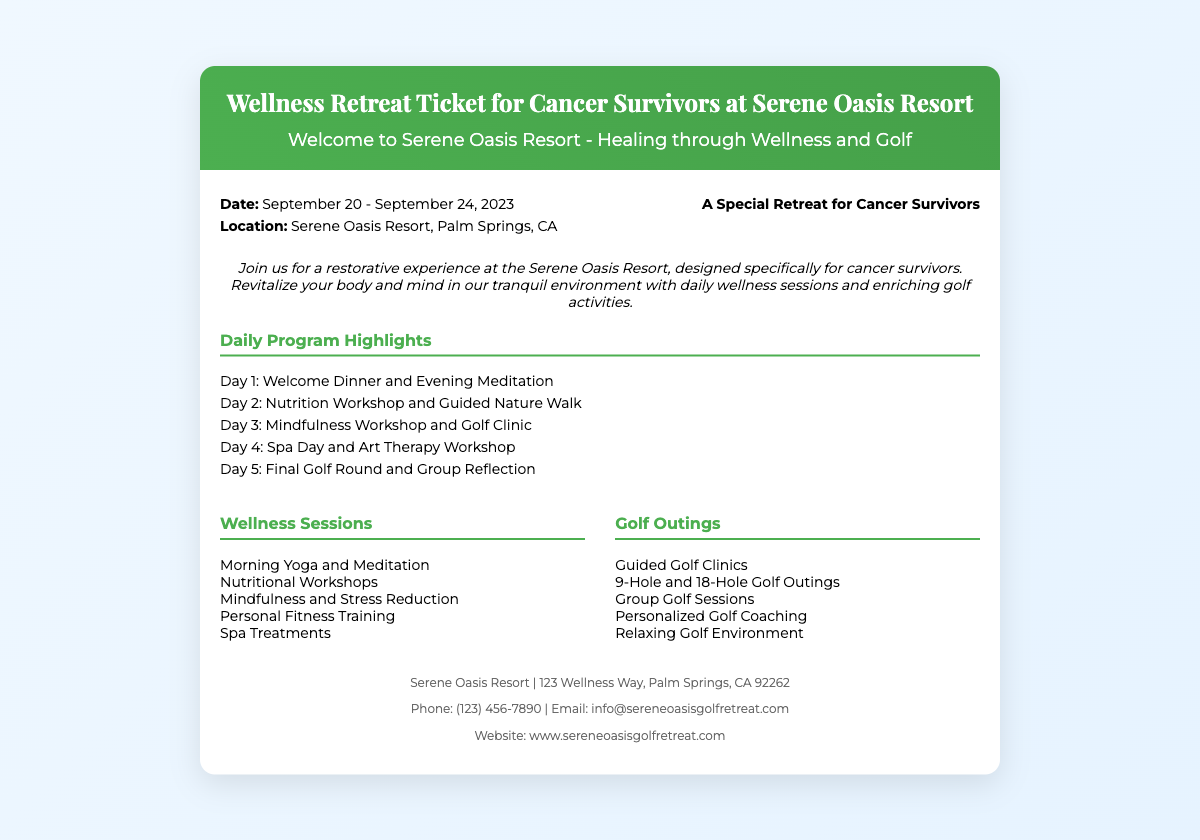what are the dates of the retreat? The document states the retreat starts on September 20 and ends on September 24, 2023.
Answer: September 20 - September 24, 2023 what is the location of the retreat? The ticket provides information about the retreat location being Serene Oasis Resort, Palm Springs, CA.
Answer: Serene Oasis Resort, Palm Springs, CA what is included in the welcome program? The introduction mentions a welcome dinner and evening meditation on the first day as part of the daily program highlights.
Answer: Welcome Dinner and Evening Meditation how many days does the retreat last? The duration of the retreat is specified in the dates section, noting it runs for five days.
Answer: Five days what is one of the wellness sessions? The document lists several wellness sessions including morning yoga and meditation, which is an example.
Answer: Morning Yoga and Meditation what type of golf activities are offered? The golf outings section mentions guided golf clinics as one of the activities available during the retreat.
Answer: Guided Golf Clinics what type of session is held on the third day? The daily program highlights state that a mindfulness workshop and golf clinic are scheduled for Day 3.
Answer: Mindfulness Workshop and Golf Clinic what can participants expect from their final day? The document mentions that the final day includes a final golf round and group reflection.
Answer: Final Golf Round and Group Reflection 